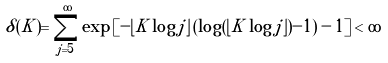<formula> <loc_0><loc_0><loc_500><loc_500>\delta ( K ) = \sum _ { j = 5 } ^ { \infty } \exp \left [ - \lfloor K \log j \rfloor \left ( \log ( \lfloor K \log j \rfloor ) - 1 \right ) - 1 \right ] < \infty</formula> 